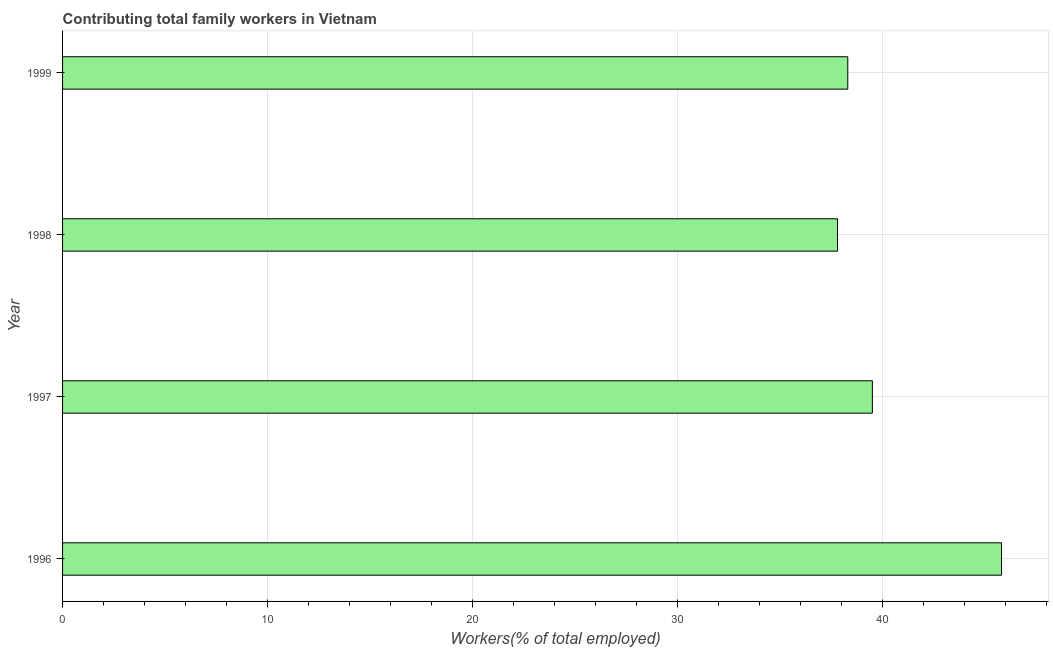Does the graph contain grids?
Offer a terse response. Yes. What is the title of the graph?
Your answer should be very brief. Contributing total family workers in Vietnam. What is the label or title of the X-axis?
Provide a short and direct response. Workers(% of total employed). What is the contributing family workers in 1997?
Give a very brief answer. 39.5. Across all years, what is the maximum contributing family workers?
Your answer should be very brief. 45.8. Across all years, what is the minimum contributing family workers?
Provide a short and direct response. 37.8. In which year was the contributing family workers maximum?
Give a very brief answer. 1996. What is the sum of the contributing family workers?
Ensure brevity in your answer.  161.4. What is the average contributing family workers per year?
Give a very brief answer. 40.35. What is the median contributing family workers?
Offer a terse response. 38.9. Do a majority of the years between 1999 and 1997 (inclusive) have contributing family workers greater than 32 %?
Make the answer very short. Yes. What is the ratio of the contributing family workers in 1996 to that in 1999?
Ensure brevity in your answer.  1.2. Is the sum of the contributing family workers in 1996 and 1998 greater than the maximum contributing family workers across all years?
Your answer should be compact. Yes. How many bars are there?
Ensure brevity in your answer.  4. Are all the bars in the graph horizontal?
Provide a succinct answer. Yes. How many years are there in the graph?
Make the answer very short. 4. What is the Workers(% of total employed) of 1996?
Your answer should be compact. 45.8. What is the Workers(% of total employed) in 1997?
Provide a succinct answer. 39.5. What is the Workers(% of total employed) of 1998?
Keep it short and to the point. 37.8. What is the Workers(% of total employed) of 1999?
Keep it short and to the point. 38.3. What is the difference between the Workers(% of total employed) in 1996 and 1998?
Provide a short and direct response. 8. What is the difference between the Workers(% of total employed) in 1996 and 1999?
Provide a succinct answer. 7.5. What is the difference between the Workers(% of total employed) in 1997 and 1998?
Your response must be concise. 1.7. What is the difference between the Workers(% of total employed) in 1997 and 1999?
Offer a very short reply. 1.2. What is the difference between the Workers(% of total employed) in 1998 and 1999?
Ensure brevity in your answer.  -0.5. What is the ratio of the Workers(% of total employed) in 1996 to that in 1997?
Give a very brief answer. 1.16. What is the ratio of the Workers(% of total employed) in 1996 to that in 1998?
Ensure brevity in your answer.  1.21. What is the ratio of the Workers(% of total employed) in 1996 to that in 1999?
Offer a terse response. 1.2. What is the ratio of the Workers(% of total employed) in 1997 to that in 1998?
Your answer should be very brief. 1.04. What is the ratio of the Workers(% of total employed) in 1997 to that in 1999?
Offer a terse response. 1.03. 